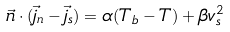Convert formula to latex. <formula><loc_0><loc_0><loc_500><loc_500>\vec { n } \cdot ( \vec { j } _ { n } - \vec { j } _ { s } ) = \alpha ( T _ { b } - T ) + \beta v _ { s } ^ { 2 }</formula> 